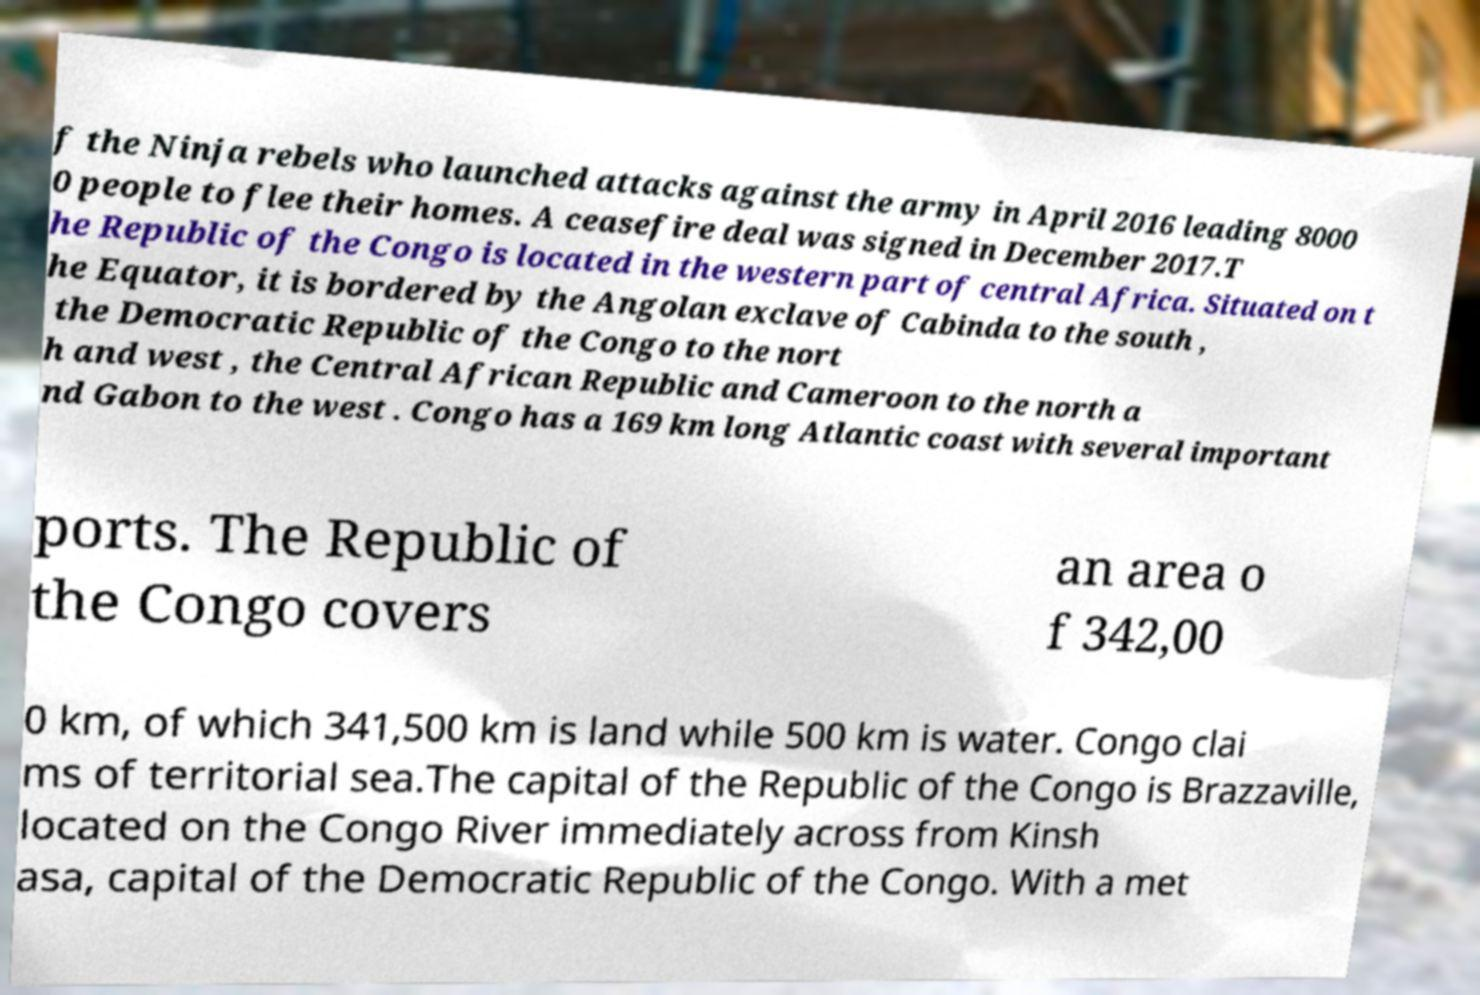Could you extract and type out the text from this image? f the Ninja rebels who launched attacks against the army in April 2016 leading 8000 0 people to flee their homes. A ceasefire deal was signed in December 2017.T he Republic of the Congo is located in the western part of central Africa. Situated on t he Equator, it is bordered by the Angolan exclave of Cabinda to the south , the Democratic Republic of the Congo to the nort h and west , the Central African Republic and Cameroon to the north a nd Gabon to the west . Congo has a 169 km long Atlantic coast with several important ports. The Republic of the Congo covers an area o f 342,00 0 km, of which 341,500 km is land while 500 km is water. Congo clai ms of territorial sea.The capital of the Republic of the Congo is Brazzaville, located on the Congo River immediately across from Kinsh asa, capital of the Democratic Republic of the Congo. With a met 